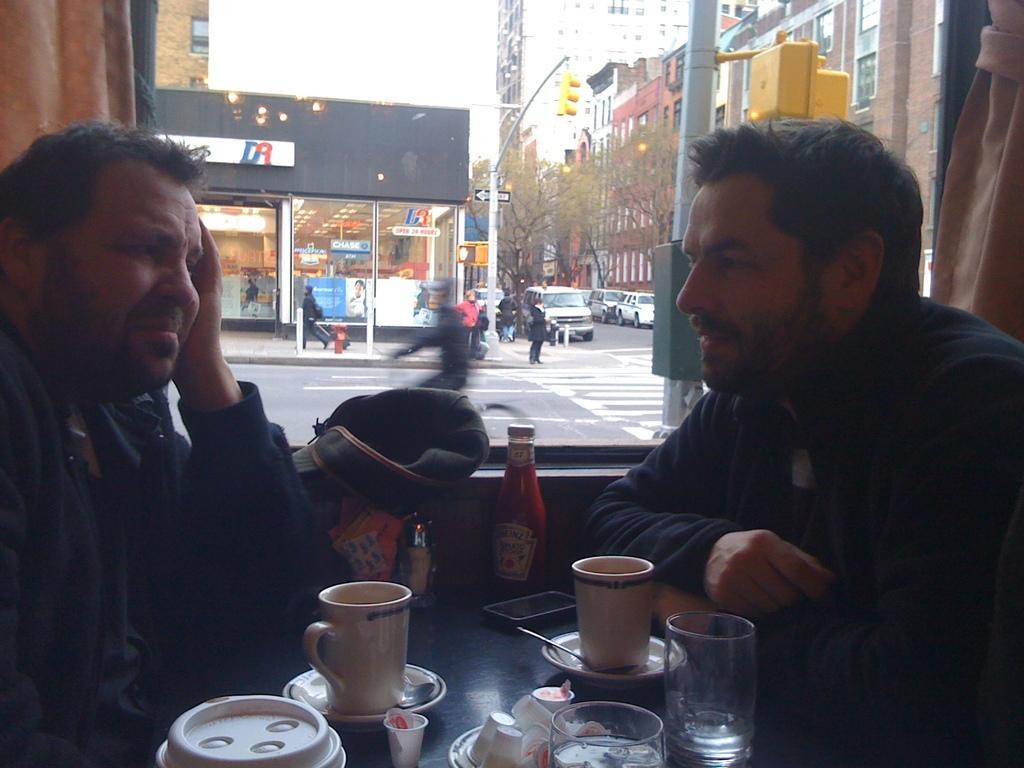Could you give a brief overview of what you see in this image? In this image there are two persons in a shop sitting around the table, on the table there are few cups, glasses and some other objects, outside the shop there are few trees, buildings, a traffic signal, few people and vehicles on the road. 